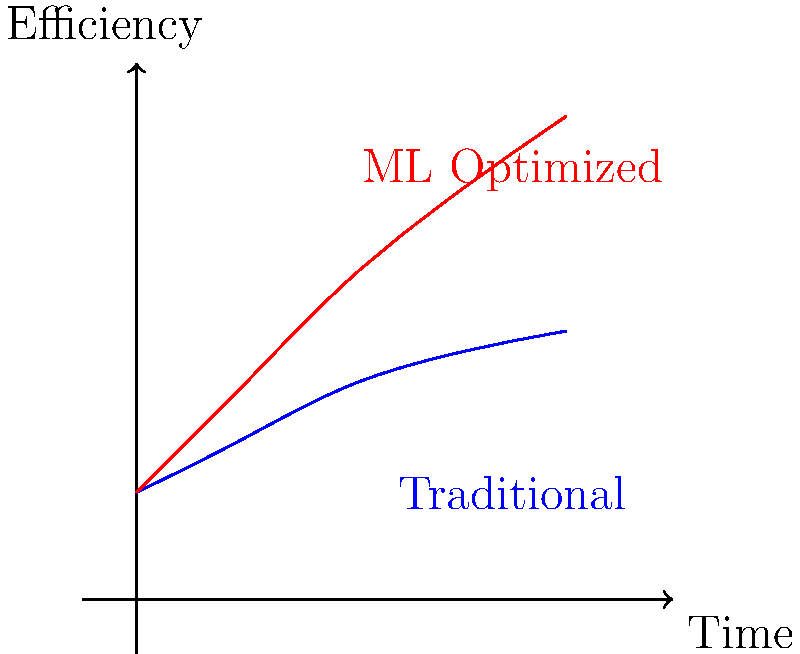In the graph above, which curve represents the efficiency of 3D character rigging optimized using machine learning techniques, and how does it compare to the traditional method in terms of improving animation smoothness over time? To answer this question, let's analyze the graph step-by-step:

1. The graph shows two curves plotted on axes representing Time (x-axis) and Efficiency (y-axis).

2. The blue curve represents the traditional method of 3D character rigging. It shows a gradual increase in efficiency over time, but the rate of improvement slows down as time progresses.

3. The red curve represents the ML-optimized method of 3D character rigging. It shows a steeper increase in efficiency over time, surpassing the traditional method.

4. Comparing the two curves:
   a) The ML-optimized curve (red) starts at the same point as the traditional curve but rises more quickly.
   b) As time progresses, the gap between the two curves widens, indicating that the ML-optimized method becomes increasingly more efficient.

5. In terms of improving animation smoothness:
   a) Higher efficiency correlates with smoother animations.
   b) The ML-optimized method achieves higher efficiency levels faster and continues to improve at a higher rate.

6. By the end of the time frame shown, the ML-optimized method (red curve) reaches a significantly higher efficiency level compared to the traditional method (blue curve).

Therefore, the red curve represents the efficiency of 3D character rigging optimized using machine learning techniques. It demonstrates superior performance in improving animation smoothness over time compared to the traditional method.
Answer: Red curve; shows higher efficiency and faster improvement rate. 